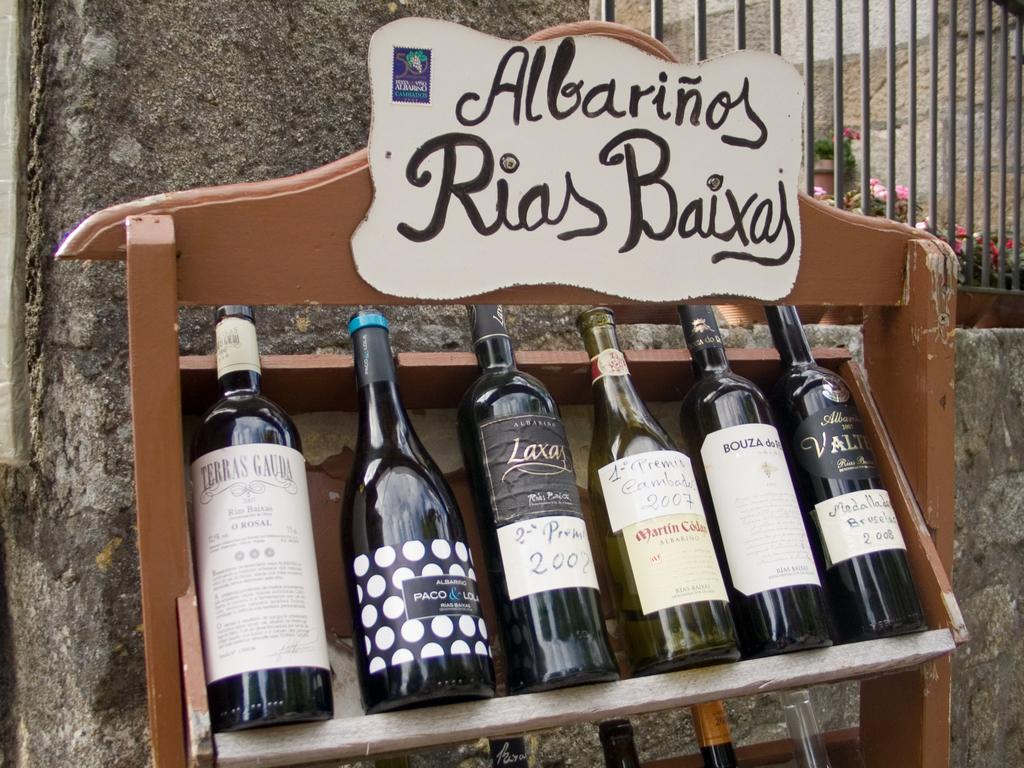What objects can be seen in the image? There are bottles in the image. Can you see a deer interacting with the bottles in the image? There is no deer present in the image. What type of canvas is used to create the background of the image? The image does not depict a canvas or any background material; it only shows bottles. 